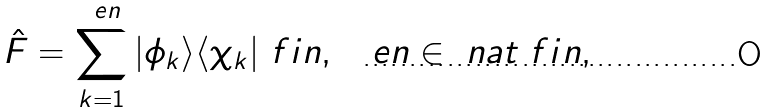<formula> <loc_0><loc_0><loc_500><loc_500>\hat { F } = \sum _ { k = 1 } ^ { \ e n } | \phi _ { k } \rangle \langle \chi _ { k } | \ f i n , \quad e n \in \ n a t \ f i n ,</formula> 